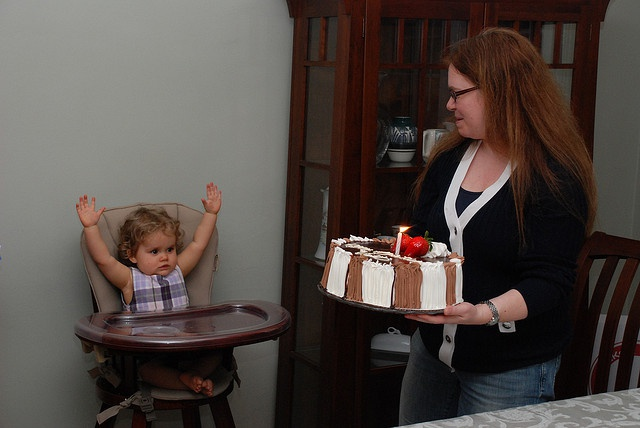Describe the objects in this image and their specific colors. I can see people in darkgray, black, maroon, and brown tones, chair in darkgray, black, gray, maroon, and brown tones, people in darkgray, black, brown, maroon, and gray tones, chair in darkgray, black, and gray tones, and cake in darkgray, lightgray, brown, and maroon tones in this image. 